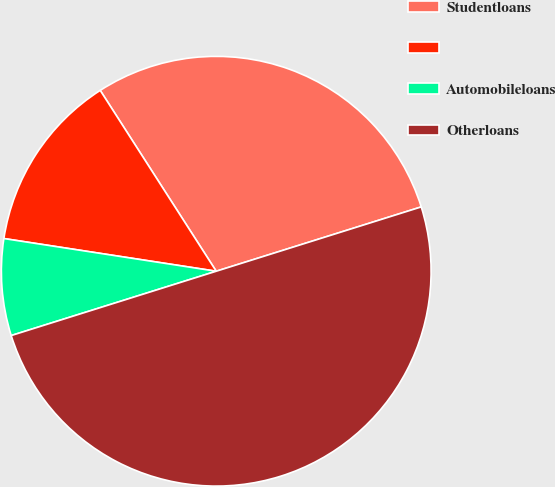<chart> <loc_0><loc_0><loc_500><loc_500><pie_chart><fcel>Studentloans<fcel>Unnamed: 1<fcel>Automobileloans<fcel>Otherloans<nl><fcel>29.24%<fcel>13.49%<fcel>7.27%<fcel>50.0%<nl></chart> 